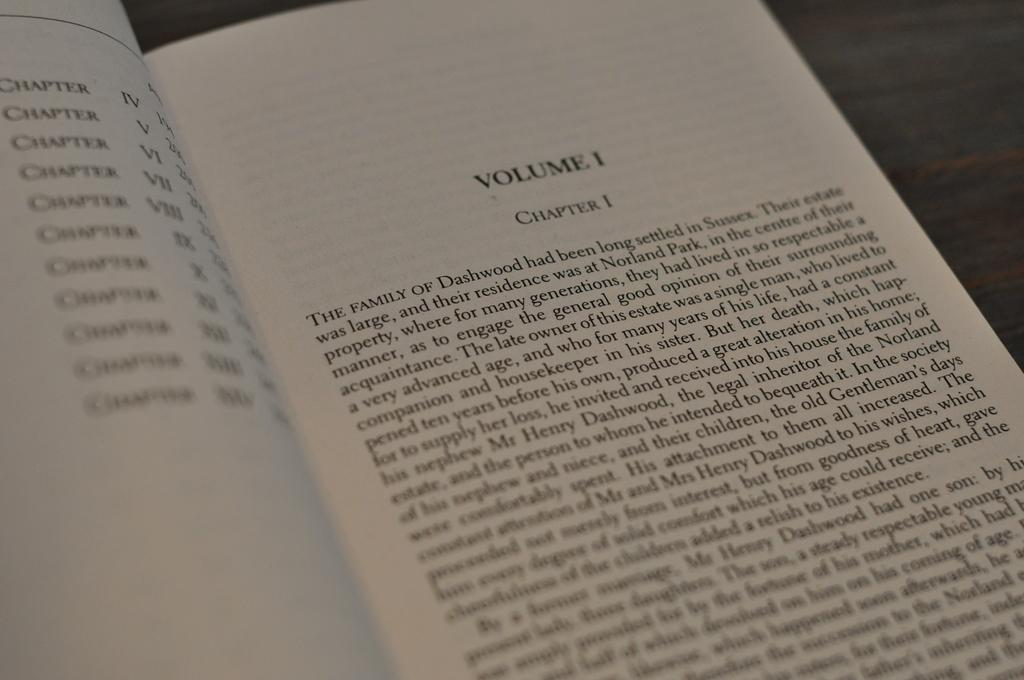Provide a one-sentence caption for the provided image. A book opened up to Volume one chapter one. 